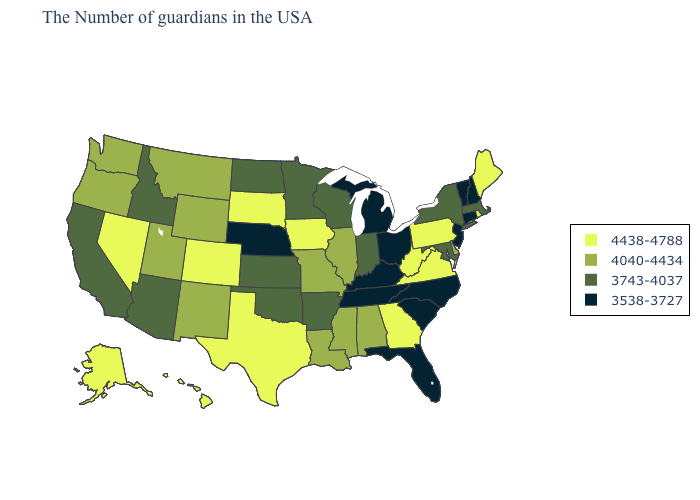Name the states that have a value in the range 4438-4788?
Give a very brief answer. Maine, Rhode Island, Pennsylvania, Virginia, West Virginia, Georgia, Iowa, Texas, South Dakota, Colorado, Nevada, Alaska, Hawaii. What is the value of New Jersey?
Answer briefly. 3538-3727. Which states hav the highest value in the Northeast?
Write a very short answer. Maine, Rhode Island, Pennsylvania. Among the states that border Wisconsin , does Illinois have the lowest value?
Give a very brief answer. No. Among the states that border New Mexico , does Colorado have the lowest value?
Concise answer only. No. Name the states that have a value in the range 3538-3727?
Concise answer only. New Hampshire, Vermont, Connecticut, New Jersey, North Carolina, South Carolina, Ohio, Florida, Michigan, Kentucky, Tennessee, Nebraska. What is the value of New Hampshire?
Answer briefly. 3538-3727. Does Illinois have the highest value in the USA?
Concise answer only. No. What is the value of Louisiana?
Short answer required. 4040-4434. Name the states that have a value in the range 4040-4434?
Short answer required. Delaware, Alabama, Illinois, Mississippi, Louisiana, Missouri, Wyoming, New Mexico, Utah, Montana, Washington, Oregon. Is the legend a continuous bar?
Keep it brief. No. Does Virginia have the same value as Idaho?
Give a very brief answer. No. Is the legend a continuous bar?
Keep it brief. No. What is the lowest value in states that border Iowa?
Keep it brief. 3538-3727. Among the states that border Minnesota , which have the lowest value?
Keep it brief. Wisconsin, North Dakota. 